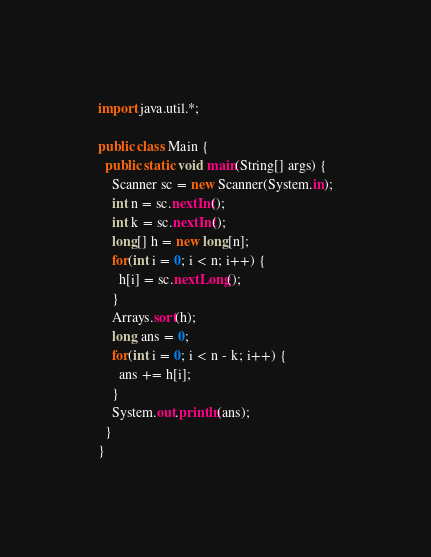Convert code to text. <code><loc_0><loc_0><loc_500><loc_500><_Java_>import java.util.*;

public class Main {
  public static void main(String[] args) {
    Scanner sc = new Scanner(System.in);
    int n = sc.nextInt();
    int k = sc.nextInt();
    long[] h = new long[n];
    for(int i = 0; i < n; i++) {
      h[i] = sc.nextLong();
    }
    Arrays.sort(h);
    long ans = 0;
    for(int i = 0; i < n - k; i++) {
      ans += h[i];
    }
    System.out.println(ans);
  }
}</code> 